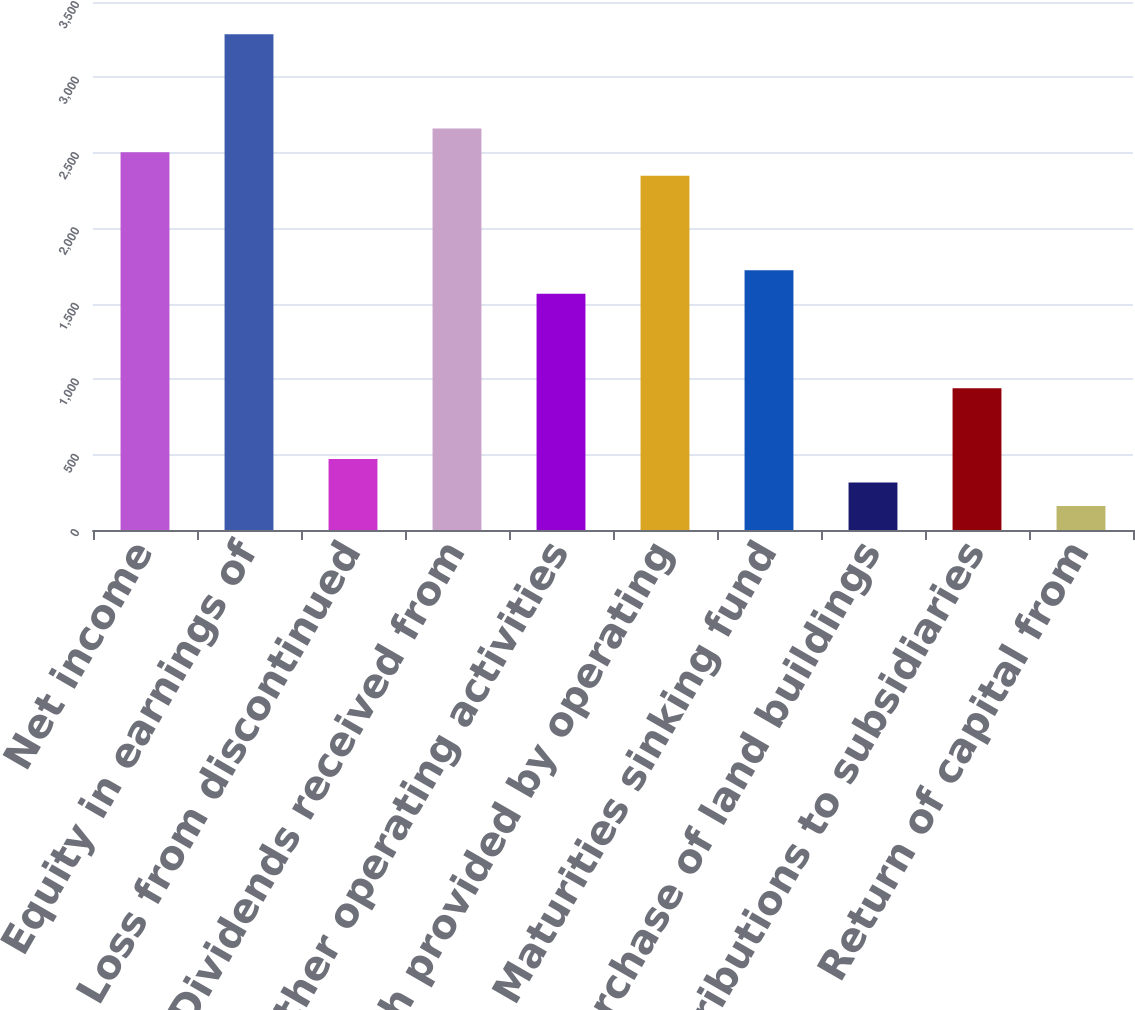Convert chart. <chart><loc_0><loc_0><loc_500><loc_500><bar_chart><fcel>Net income<fcel>Equity in earnings of<fcel>Loss from discontinued<fcel>Dividends received from<fcel>Other operating activities<fcel>Net cash provided by operating<fcel>Maturities sinking fund<fcel>Purchase of land buildings<fcel>Contributions to subsidiaries<fcel>Return of capital from<nl><fcel>2504.4<fcel>3286.4<fcel>471.2<fcel>2660.8<fcel>1566<fcel>2348<fcel>1722.4<fcel>314.8<fcel>940.4<fcel>158.4<nl></chart> 